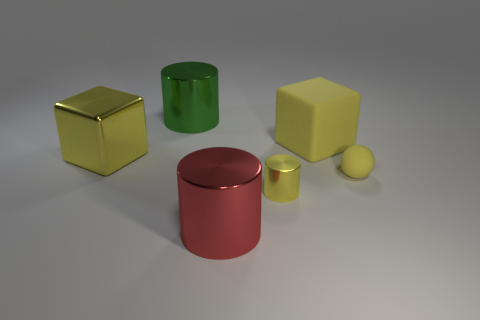Add 2 cylinders. How many objects exist? 8 Subtract all blocks. How many objects are left? 4 Subtract 0 gray spheres. How many objects are left? 6 Subtract all small yellow cylinders. Subtract all small matte balls. How many objects are left? 4 Add 5 small yellow matte balls. How many small yellow matte balls are left? 6 Add 4 small metal things. How many small metal things exist? 5 